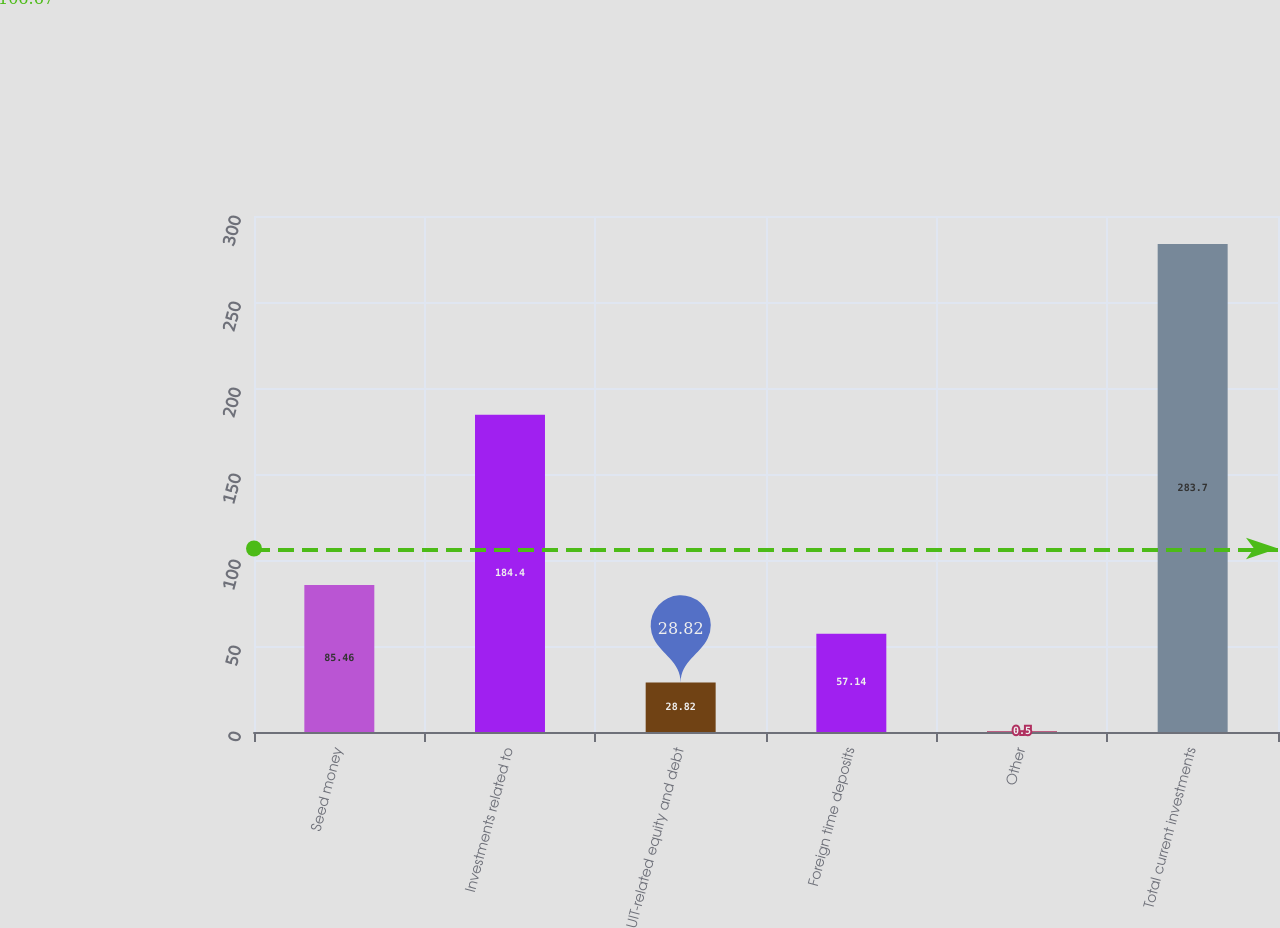Convert chart. <chart><loc_0><loc_0><loc_500><loc_500><bar_chart><fcel>Seed money<fcel>Investments related to<fcel>UIT-related equity and debt<fcel>Foreign time deposits<fcel>Other<fcel>Total current investments<nl><fcel>85.46<fcel>184.4<fcel>28.82<fcel>57.14<fcel>0.5<fcel>283.7<nl></chart> 